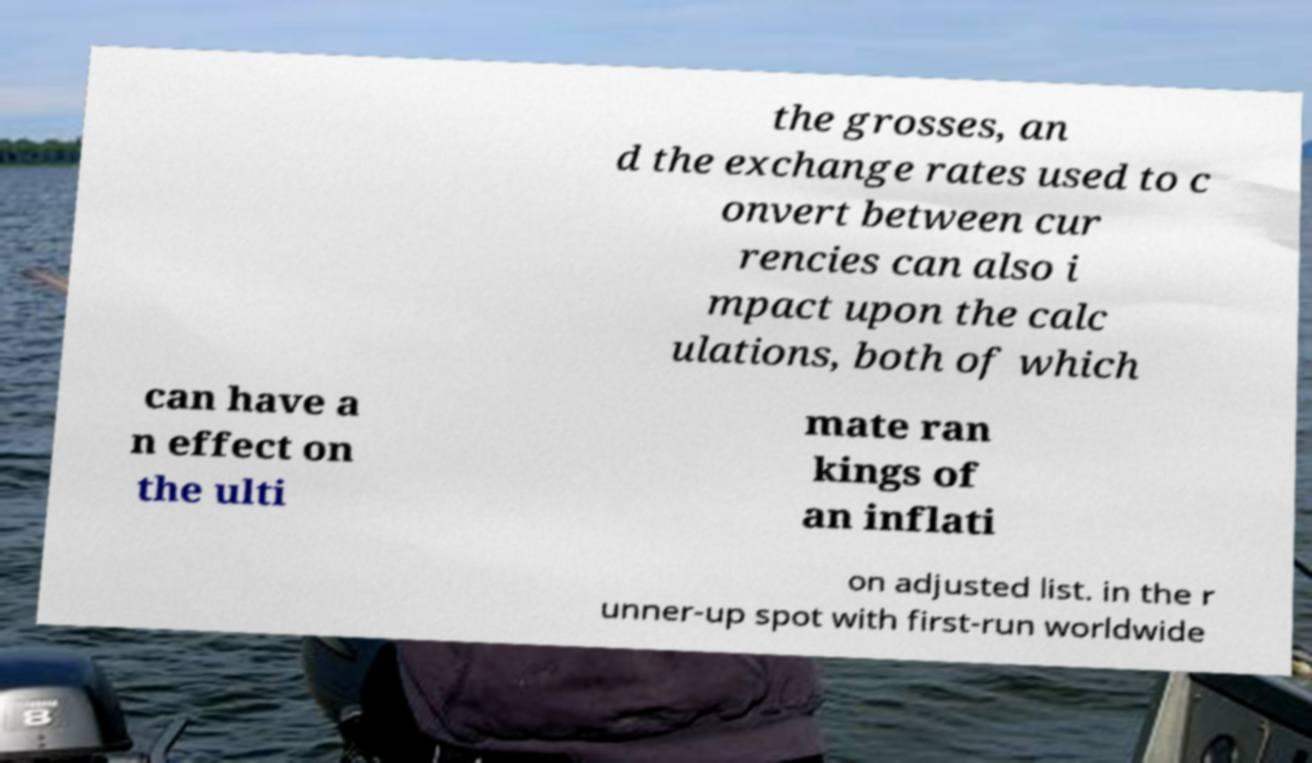What messages or text are displayed in this image? I need them in a readable, typed format. the grosses, an d the exchange rates used to c onvert between cur rencies can also i mpact upon the calc ulations, both of which can have a n effect on the ulti mate ran kings of an inflati on adjusted list. in the r unner-up spot with first-run worldwide 